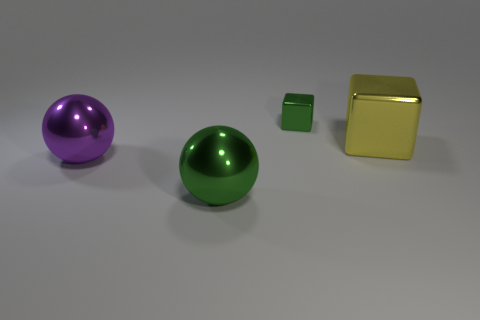Subtract all yellow cubes. How many cubes are left? 1 Subtract 2 blocks. How many blocks are left? 0 Add 4 small metal things. How many objects exist? 8 Subtract all green blocks. Subtract all gray cylinders. How many blocks are left? 1 Subtract all cyan cylinders. How many yellow balls are left? 0 Subtract all green rubber cylinders. Subtract all tiny blocks. How many objects are left? 3 Add 1 tiny objects. How many tiny objects are left? 2 Add 3 green metal blocks. How many green metal blocks exist? 4 Subtract 0 blue spheres. How many objects are left? 4 